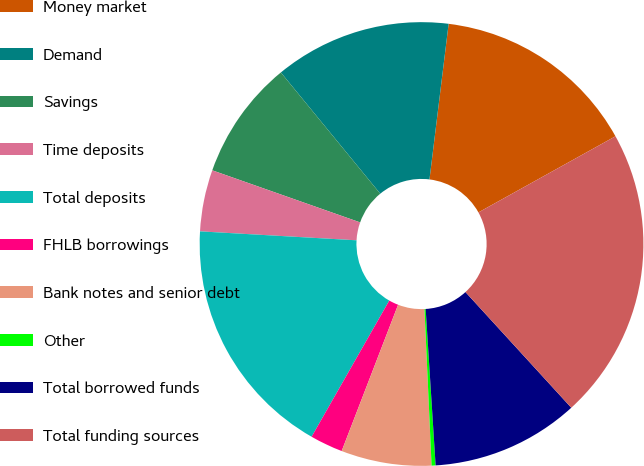Convert chart. <chart><loc_0><loc_0><loc_500><loc_500><pie_chart><fcel>Money market<fcel>Demand<fcel>Savings<fcel>Time deposits<fcel>Total deposits<fcel>FHLB borrowings<fcel>Bank notes and senior debt<fcel>Other<fcel>Total borrowed funds<fcel>Total funding sources<nl><fcel>14.98%<fcel>12.88%<fcel>8.68%<fcel>4.48%<fcel>17.66%<fcel>2.39%<fcel>6.58%<fcel>0.29%<fcel>10.78%<fcel>21.28%<nl></chart> 